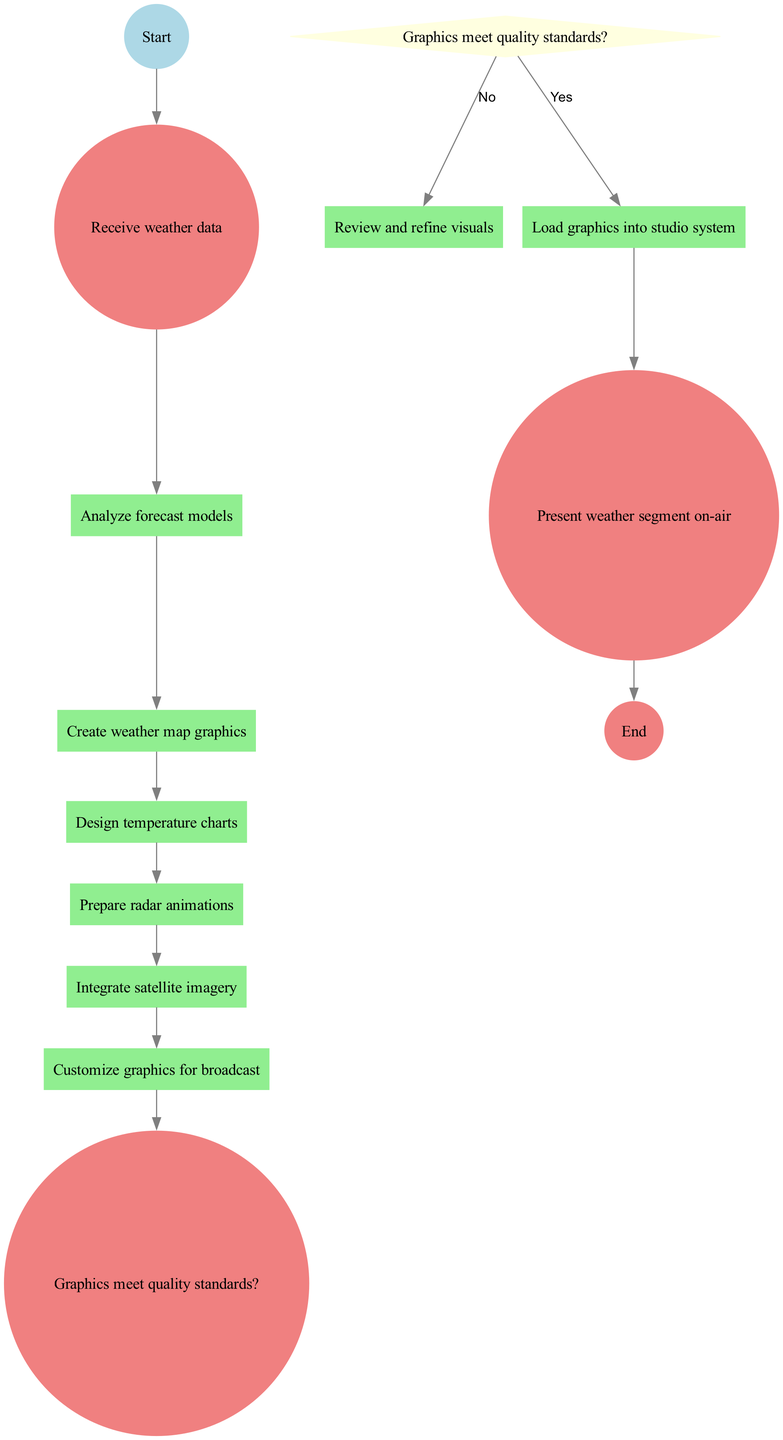What is the starting activity in the diagram? The diagram begins with the node labeled "Receive weather data," which is the first activity in the sequence.
Answer: Receive weather data How many activities are present in the diagram? There are eight activities listed in the diagram, illustrating the steps for creating and integrating weather graphics.
Answer: 8 What decision is made after customizing graphics for broadcast? The diagram has a decision node that asks "Graphics meet quality standards?" after the activity of customizing graphics, leading to further actions.
Answer: Graphics meet quality standards? What is the final node in the activity diagram? The final step in the diagram, indicated by the end node, is "Present weather segment on-air."
Answer: Present weather segment on-air What happens if the graphics do not meet quality standards? If the graphics do not meet quality standards, the flow returns to "Review and refine visuals," allowing for necessary adjustments before proceeding.
Answer: Review and refine visuals Which activity comes directly after designing temperature charts? The activity that follows "Design temperature charts" is "Prepare radar animations," forming a sequential step in the process.
Answer: Prepare radar animations How many edges connect the decision node to other nodes? There are two edges stemming from the decision node: one leading to "Load graphics into studio system" for a positive outcome and another returning to "Review and refine visuals" for a negative outcome.
Answer: 2 Which activity immediately precedes integrating satellite imagery? "Prepare radar animations" is the activity that immediately comes before "Integrate satellite imagery" in the sequence of tasks.
Answer: Prepare radar animations What is the first activity after the data is received? The immediate next activity after "Receive weather data" is "Analyze forecast models," moving the process along in the diagram.
Answer: Analyze forecast models 